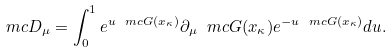Convert formula to latex. <formula><loc_0><loc_0><loc_500><loc_500>\ m c D _ { \mu } = \int _ { 0 } ^ { 1 } e ^ { u \ m c G ( x _ { \kappa } ) } \partial _ { \mu } \ m c G ( x _ { \kappa } ) e ^ { - u \ m c G ( x _ { \kappa } ) } d u .</formula> 